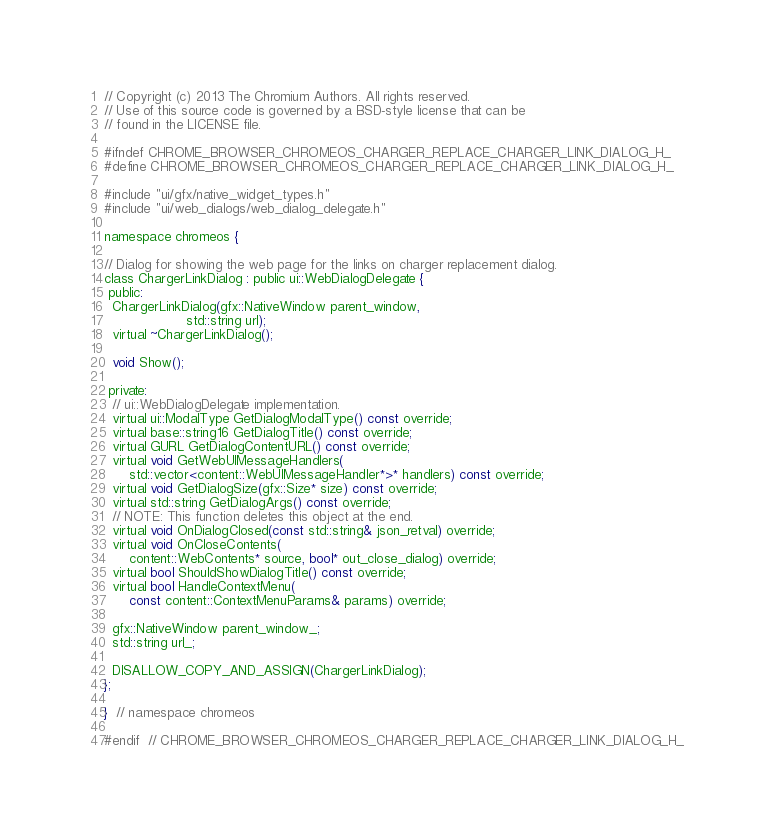Convert code to text. <code><loc_0><loc_0><loc_500><loc_500><_C_>// Copyright (c) 2013 The Chromium Authors. All rights reserved.
// Use of this source code is governed by a BSD-style license that can be
// found in the LICENSE file.

#ifndef CHROME_BROWSER_CHROMEOS_CHARGER_REPLACE_CHARGER_LINK_DIALOG_H_
#define CHROME_BROWSER_CHROMEOS_CHARGER_REPLACE_CHARGER_LINK_DIALOG_H_

#include "ui/gfx/native_widget_types.h"
#include "ui/web_dialogs/web_dialog_delegate.h"

namespace chromeos {

// Dialog for showing the web page for the links on charger replacement dialog.
class ChargerLinkDialog : public ui::WebDialogDelegate {
 public:
  ChargerLinkDialog(gfx::NativeWindow parent_window,
                    std::string url);
  virtual ~ChargerLinkDialog();

  void Show();

 private:
  // ui::WebDialogDelegate implementation.
  virtual ui::ModalType GetDialogModalType() const override;
  virtual base::string16 GetDialogTitle() const override;
  virtual GURL GetDialogContentURL() const override;
  virtual void GetWebUIMessageHandlers(
      std::vector<content::WebUIMessageHandler*>* handlers) const override;
  virtual void GetDialogSize(gfx::Size* size) const override;
  virtual std::string GetDialogArgs() const override;
  // NOTE: This function deletes this object at the end.
  virtual void OnDialogClosed(const std::string& json_retval) override;
  virtual void OnCloseContents(
      content::WebContents* source, bool* out_close_dialog) override;
  virtual bool ShouldShowDialogTitle() const override;
  virtual bool HandleContextMenu(
      const content::ContextMenuParams& params) override;

  gfx::NativeWindow parent_window_;
  std::string url_;

  DISALLOW_COPY_AND_ASSIGN(ChargerLinkDialog);
};

}  // namespace chromeos

#endif  // CHROME_BROWSER_CHROMEOS_CHARGER_REPLACE_CHARGER_LINK_DIALOG_H_
</code> 